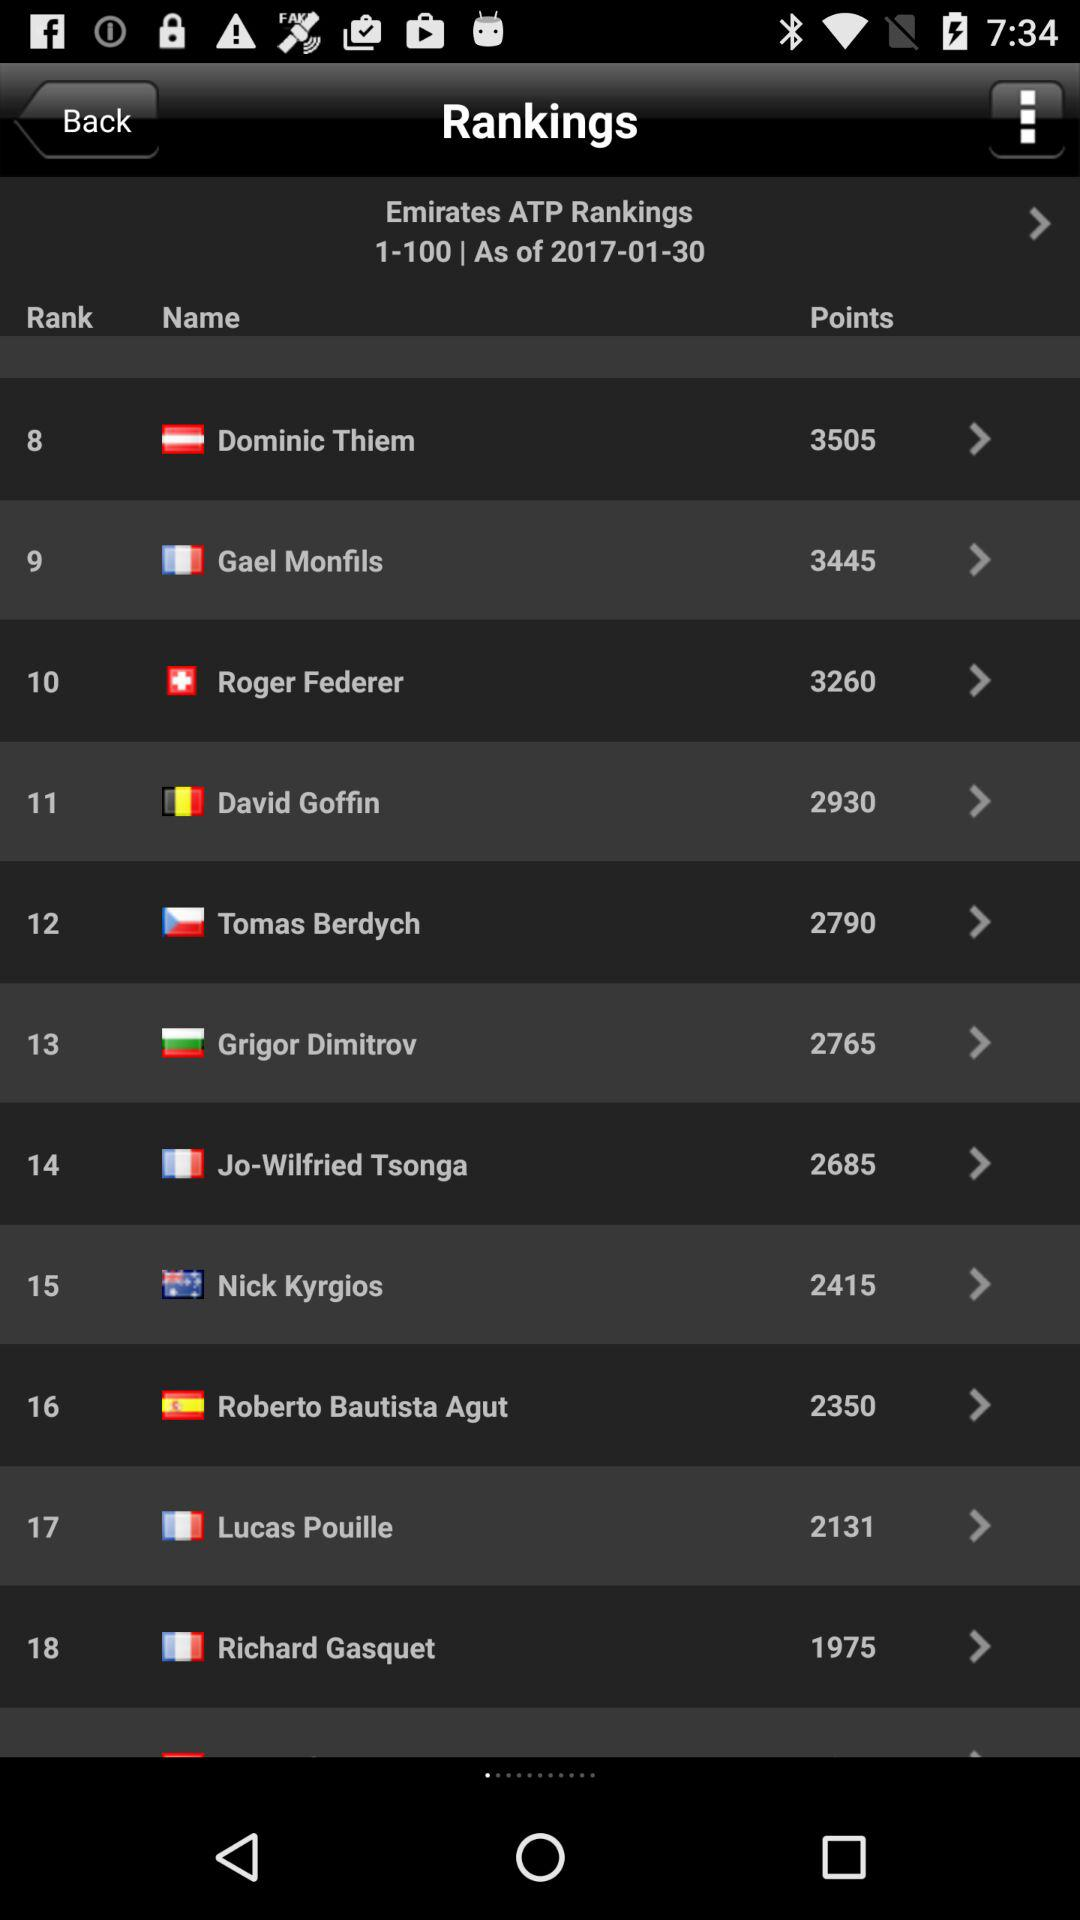What is the rank of Nick Kyrgios? The rank is 15. 